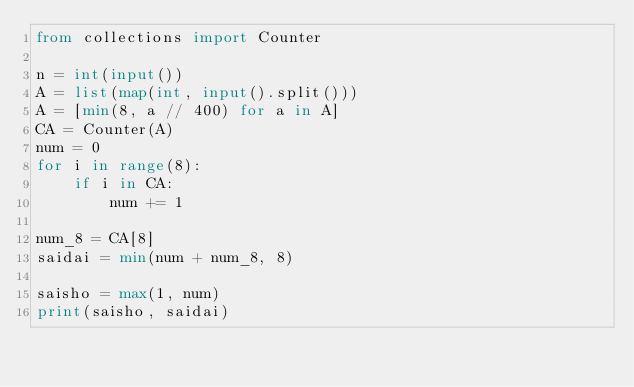Convert code to text. <code><loc_0><loc_0><loc_500><loc_500><_Python_>from collections import Counter

n = int(input())
A = list(map(int, input().split()))
A = [min(8, a // 400) for a in A]
CA = Counter(A)
num = 0
for i in range(8):
    if i in CA:
        num += 1

num_8 = CA[8]
saidai = min(num + num_8, 8)

saisho = max(1, num)
print(saisho, saidai)

</code> 